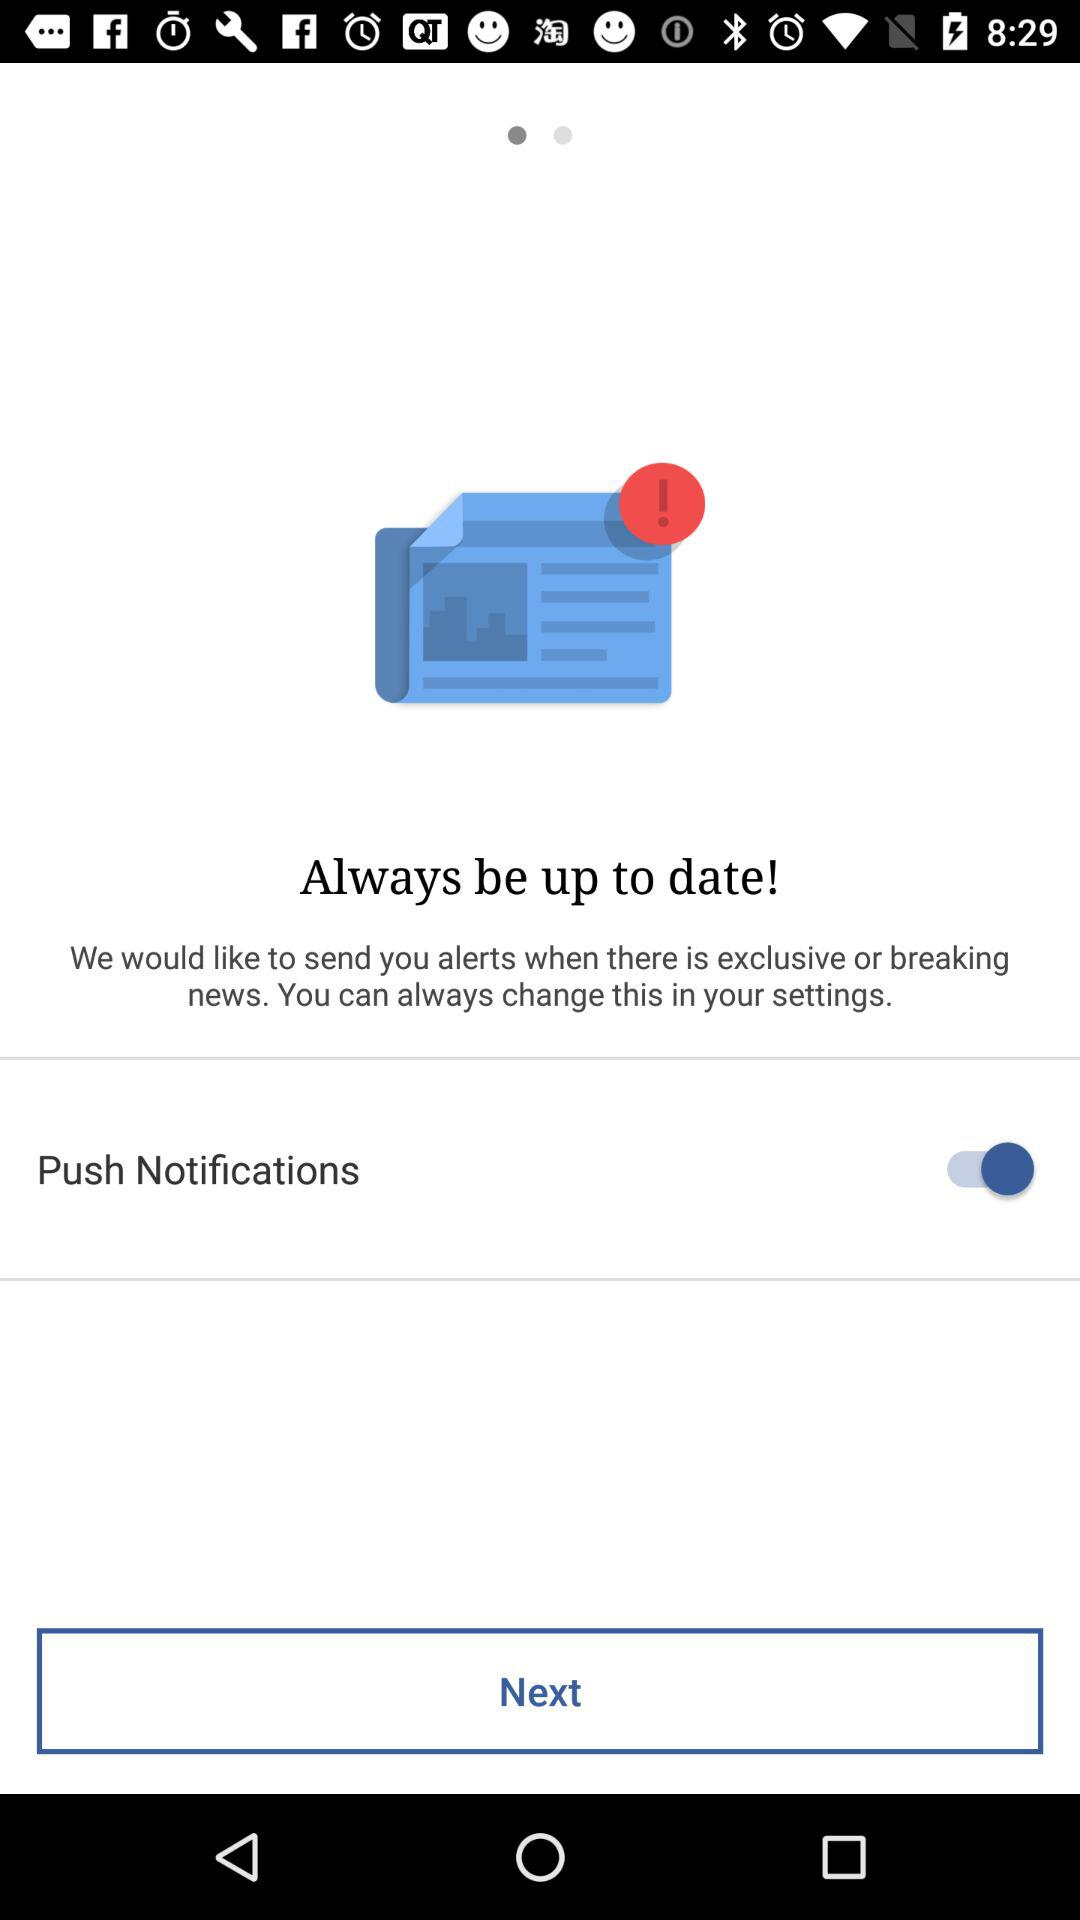How often can the application send alerts?
When the provided information is insufficient, respond with <no answer>. <no answer> 